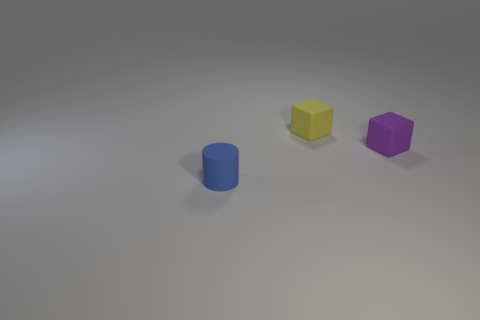Add 1 large yellow metallic objects. How many objects exist? 4 Subtract 1 cubes. How many cubes are left? 1 Subtract all purple cubes. How many cubes are left? 1 Subtract all cylinders. How many objects are left? 2 Subtract all red cylinders. How many green cubes are left? 0 Subtract 0 yellow cylinders. How many objects are left? 3 Subtract all gray cylinders. Subtract all blue spheres. How many cylinders are left? 1 Subtract all big red metallic blocks. Subtract all small blue matte cylinders. How many objects are left? 2 Add 1 small blue objects. How many small blue objects are left? 2 Add 1 small blue things. How many small blue things exist? 2 